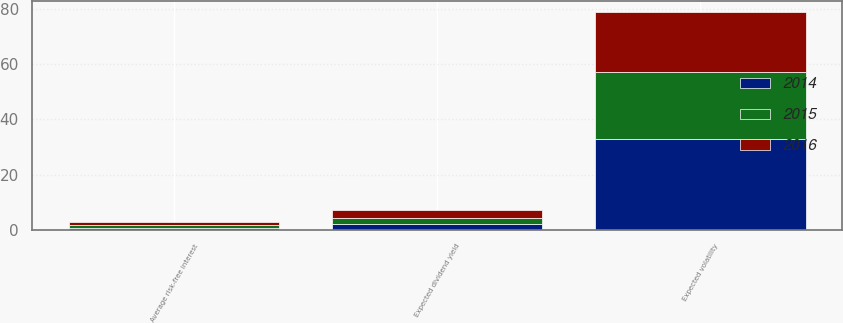Convert chart. <chart><loc_0><loc_0><loc_500><loc_500><stacked_bar_chart><ecel><fcel>Average risk-free interest<fcel>Expected dividend yield<fcel>Expected volatility<nl><fcel>2016<fcel>1.21<fcel>2.75<fcel>22<nl><fcel>2015<fcel>0.96<fcel>2.22<fcel>24<nl><fcel>2014<fcel>0.6<fcel>2.11<fcel>33<nl></chart> 